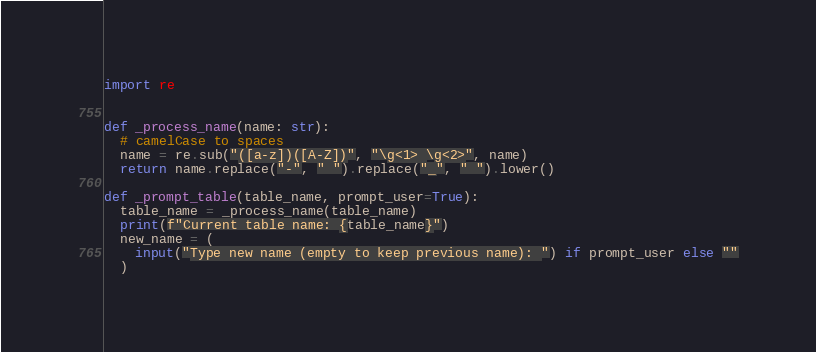Convert code to text. <code><loc_0><loc_0><loc_500><loc_500><_Python_>import re


def _process_name(name: str):
  # camelCase to spaces
  name = re.sub("([a-z])([A-Z])", "\g<1> \g<2>", name)
  return name.replace("-", " ").replace("_", " ").lower()

def _prompt_table(table_name, prompt_user=True):
  table_name = _process_name(table_name)
  print(f"Current table name: {table_name}")
  new_name = (
    input("Type new name (empty to keep previous name): ") if prompt_user else ""
  )</code> 